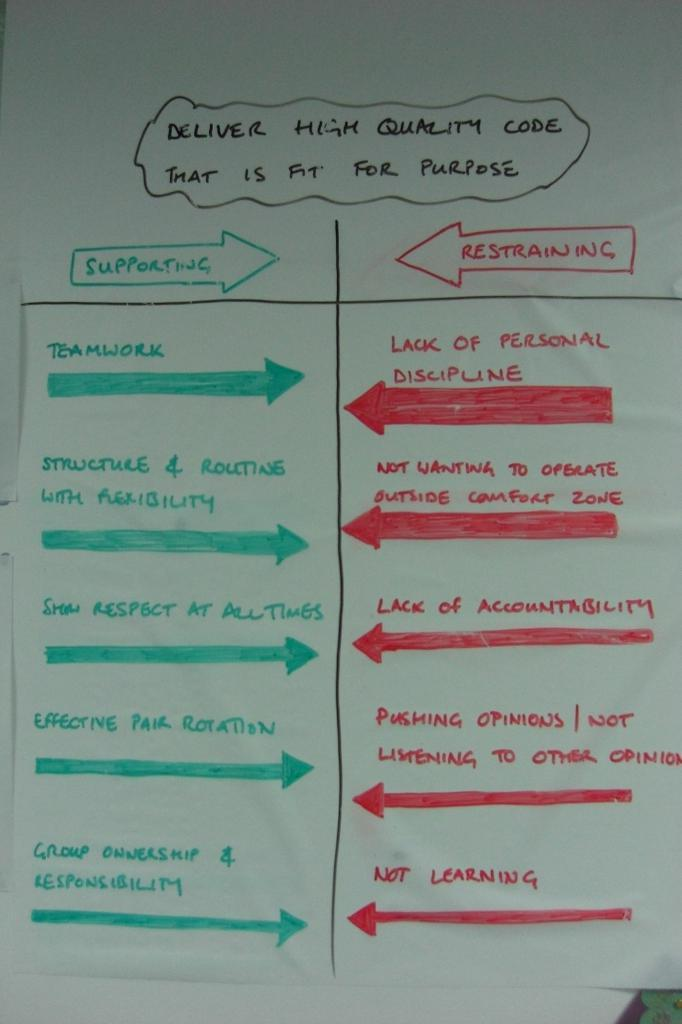Provide a one-sentence caption for the provided image. A white board has a lot of writing and says Delivery High Quality Code That is Fit For Purpose. 